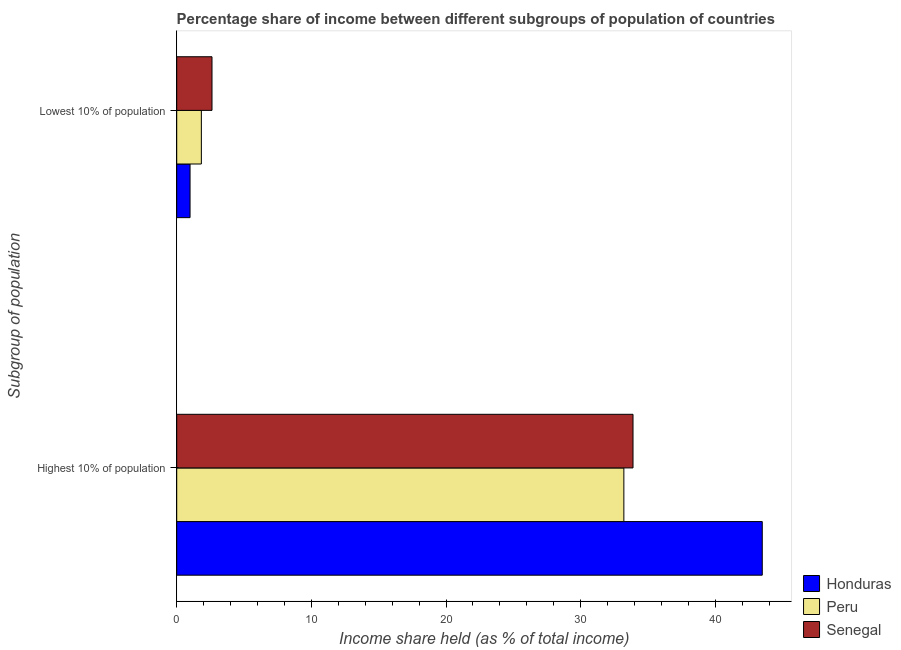How many different coloured bars are there?
Your response must be concise. 3. How many groups of bars are there?
Offer a very short reply. 2. Are the number of bars per tick equal to the number of legend labels?
Your answer should be compact. Yes. How many bars are there on the 1st tick from the top?
Your response must be concise. 3. How many bars are there on the 2nd tick from the bottom?
Provide a succinct answer. 3. What is the label of the 1st group of bars from the top?
Provide a short and direct response. Lowest 10% of population. What is the income share held by highest 10% of the population in Senegal?
Offer a very short reply. 33.89. Across all countries, what is the maximum income share held by highest 10% of the population?
Keep it short and to the point. 43.49. Across all countries, what is the minimum income share held by lowest 10% of the population?
Offer a terse response. 0.99. In which country was the income share held by lowest 10% of the population maximum?
Provide a succinct answer. Senegal. In which country was the income share held by lowest 10% of the population minimum?
Provide a succinct answer. Honduras. What is the total income share held by lowest 10% of the population in the graph?
Offer a terse response. 5.44. What is the difference between the income share held by highest 10% of the population in Senegal and that in Honduras?
Your answer should be compact. -9.6. What is the difference between the income share held by highest 10% of the population in Senegal and the income share held by lowest 10% of the population in Honduras?
Your answer should be very brief. 32.9. What is the average income share held by highest 10% of the population per country?
Give a very brief answer. 36.86. What is the difference between the income share held by highest 10% of the population and income share held by lowest 10% of the population in Senegal?
Ensure brevity in your answer.  31.27. In how many countries, is the income share held by lowest 10% of the population greater than 10 %?
Ensure brevity in your answer.  0. What is the ratio of the income share held by highest 10% of the population in Honduras to that in Peru?
Provide a succinct answer. 1.31. Is the income share held by highest 10% of the population in Senegal less than that in Honduras?
Your answer should be very brief. Yes. What does the 1st bar from the top in Highest 10% of population represents?
Offer a terse response. Senegal. What does the 3rd bar from the bottom in Lowest 10% of population represents?
Provide a short and direct response. Senegal. Are all the bars in the graph horizontal?
Your response must be concise. Yes. How many countries are there in the graph?
Make the answer very short. 3. Are the values on the major ticks of X-axis written in scientific E-notation?
Make the answer very short. No. Does the graph contain grids?
Your answer should be compact. No. Where does the legend appear in the graph?
Offer a terse response. Bottom right. How many legend labels are there?
Ensure brevity in your answer.  3. What is the title of the graph?
Your response must be concise. Percentage share of income between different subgroups of population of countries. What is the label or title of the X-axis?
Your answer should be very brief. Income share held (as % of total income). What is the label or title of the Y-axis?
Keep it short and to the point. Subgroup of population. What is the Income share held (as % of total income) in Honduras in Highest 10% of population?
Offer a terse response. 43.49. What is the Income share held (as % of total income) of Peru in Highest 10% of population?
Your answer should be compact. 33.21. What is the Income share held (as % of total income) of Senegal in Highest 10% of population?
Keep it short and to the point. 33.89. What is the Income share held (as % of total income) of Honduras in Lowest 10% of population?
Make the answer very short. 0.99. What is the Income share held (as % of total income) of Peru in Lowest 10% of population?
Provide a short and direct response. 1.83. What is the Income share held (as % of total income) of Senegal in Lowest 10% of population?
Give a very brief answer. 2.62. Across all Subgroup of population, what is the maximum Income share held (as % of total income) in Honduras?
Make the answer very short. 43.49. Across all Subgroup of population, what is the maximum Income share held (as % of total income) in Peru?
Make the answer very short. 33.21. Across all Subgroup of population, what is the maximum Income share held (as % of total income) in Senegal?
Give a very brief answer. 33.89. Across all Subgroup of population, what is the minimum Income share held (as % of total income) of Peru?
Offer a very short reply. 1.83. Across all Subgroup of population, what is the minimum Income share held (as % of total income) of Senegal?
Ensure brevity in your answer.  2.62. What is the total Income share held (as % of total income) of Honduras in the graph?
Your response must be concise. 44.48. What is the total Income share held (as % of total income) in Peru in the graph?
Provide a short and direct response. 35.04. What is the total Income share held (as % of total income) in Senegal in the graph?
Make the answer very short. 36.51. What is the difference between the Income share held (as % of total income) in Honduras in Highest 10% of population and that in Lowest 10% of population?
Offer a very short reply. 42.5. What is the difference between the Income share held (as % of total income) in Peru in Highest 10% of population and that in Lowest 10% of population?
Your response must be concise. 31.38. What is the difference between the Income share held (as % of total income) in Senegal in Highest 10% of population and that in Lowest 10% of population?
Offer a very short reply. 31.27. What is the difference between the Income share held (as % of total income) in Honduras in Highest 10% of population and the Income share held (as % of total income) in Peru in Lowest 10% of population?
Provide a short and direct response. 41.66. What is the difference between the Income share held (as % of total income) in Honduras in Highest 10% of population and the Income share held (as % of total income) in Senegal in Lowest 10% of population?
Offer a terse response. 40.87. What is the difference between the Income share held (as % of total income) in Peru in Highest 10% of population and the Income share held (as % of total income) in Senegal in Lowest 10% of population?
Your answer should be very brief. 30.59. What is the average Income share held (as % of total income) in Honduras per Subgroup of population?
Ensure brevity in your answer.  22.24. What is the average Income share held (as % of total income) of Peru per Subgroup of population?
Make the answer very short. 17.52. What is the average Income share held (as % of total income) of Senegal per Subgroup of population?
Your response must be concise. 18.25. What is the difference between the Income share held (as % of total income) of Honduras and Income share held (as % of total income) of Peru in Highest 10% of population?
Your response must be concise. 10.28. What is the difference between the Income share held (as % of total income) of Peru and Income share held (as % of total income) of Senegal in Highest 10% of population?
Provide a short and direct response. -0.68. What is the difference between the Income share held (as % of total income) in Honduras and Income share held (as % of total income) in Peru in Lowest 10% of population?
Make the answer very short. -0.84. What is the difference between the Income share held (as % of total income) of Honduras and Income share held (as % of total income) of Senegal in Lowest 10% of population?
Make the answer very short. -1.63. What is the difference between the Income share held (as % of total income) in Peru and Income share held (as % of total income) in Senegal in Lowest 10% of population?
Your answer should be very brief. -0.79. What is the ratio of the Income share held (as % of total income) of Honduras in Highest 10% of population to that in Lowest 10% of population?
Your answer should be compact. 43.93. What is the ratio of the Income share held (as % of total income) in Peru in Highest 10% of population to that in Lowest 10% of population?
Make the answer very short. 18.15. What is the ratio of the Income share held (as % of total income) in Senegal in Highest 10% of population to that in Lowest 10% of population?
Provide a short and direct response. 12.94. What is the difference between the highest and the second highest Income share held (as % of total income) in Honduras?
Ensure brevity in your answer.  42.5. What is the difference between the highest and the second highest Income share held (as % of total income) in Peru?
Ensure brevity in your answer.  31.38. What is the difference between the highest and the second highest Income share held (as % of total income) in Senegal?
Your answer should be very brief. 31.27. What is the difference between the highest and the lowest Income share held (as % of total income) in Honduras?
Your answer should be compact. 42.5. What is the difference between the highest and the lowest Income share held (as % of total income) of Peru?
Make the answer very short. 31.38. What is the difference between the highest and the lowest Income share held (as % of total income) in Senegal?
Make the answer very short. 31.27. 